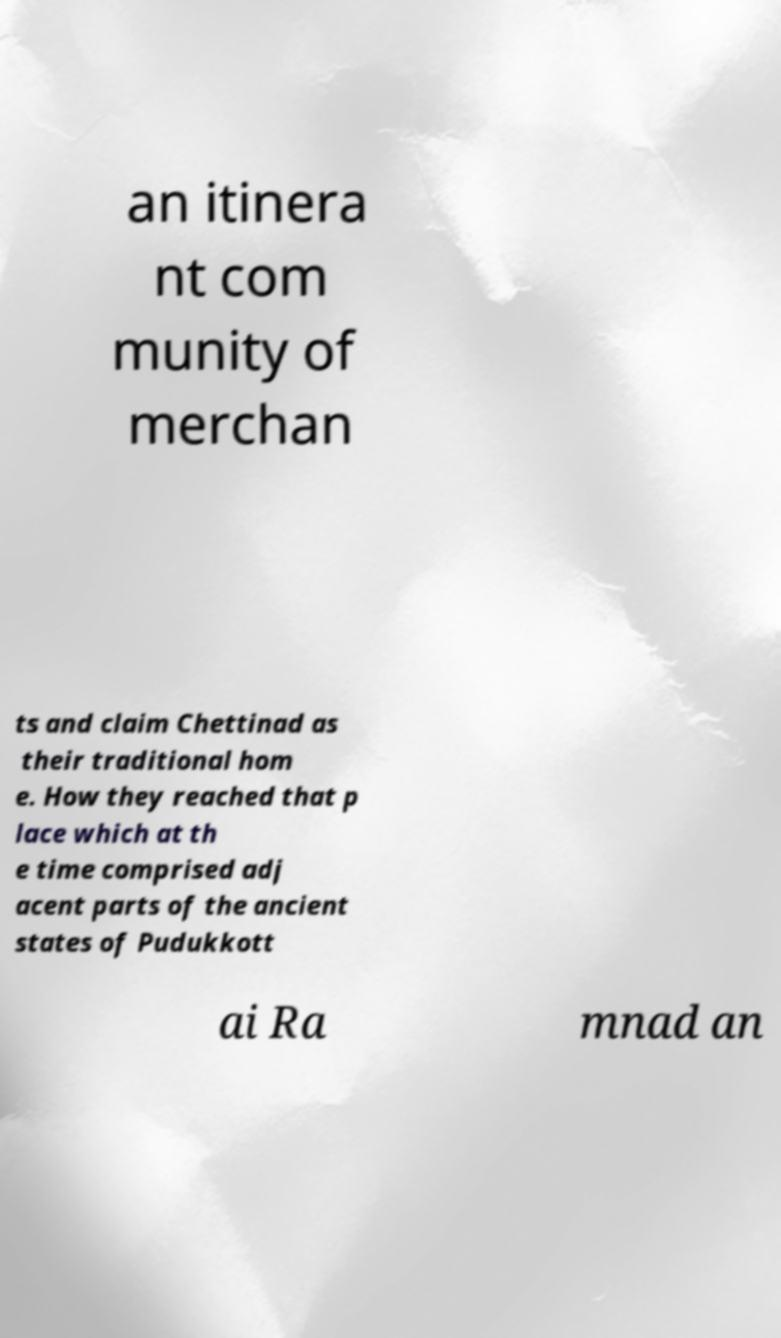Please identify and transcribe the text found in this image. an itinera nt com munity of merchan ts and claim Chettinad as their traditional hom e. How they reached that p lace which at th e time comprised adj acent parts of the ancient states of Pudukkott ai Ra mnad an 